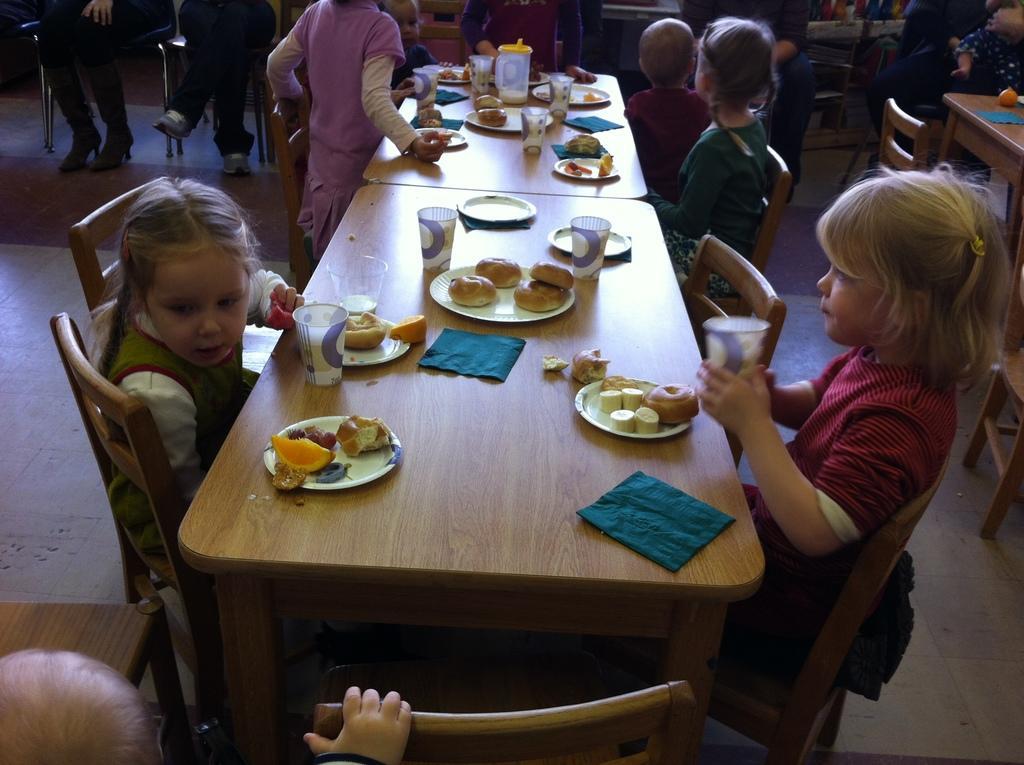Could you give a brief overview of what you see in this image? In a picture there are children sitting on the chairs in front of the tables filled with food items and glasses and plates, in the left corner of the picture one glass is standing in a purple dress and in the right corner of the picture there is another table and chair. 